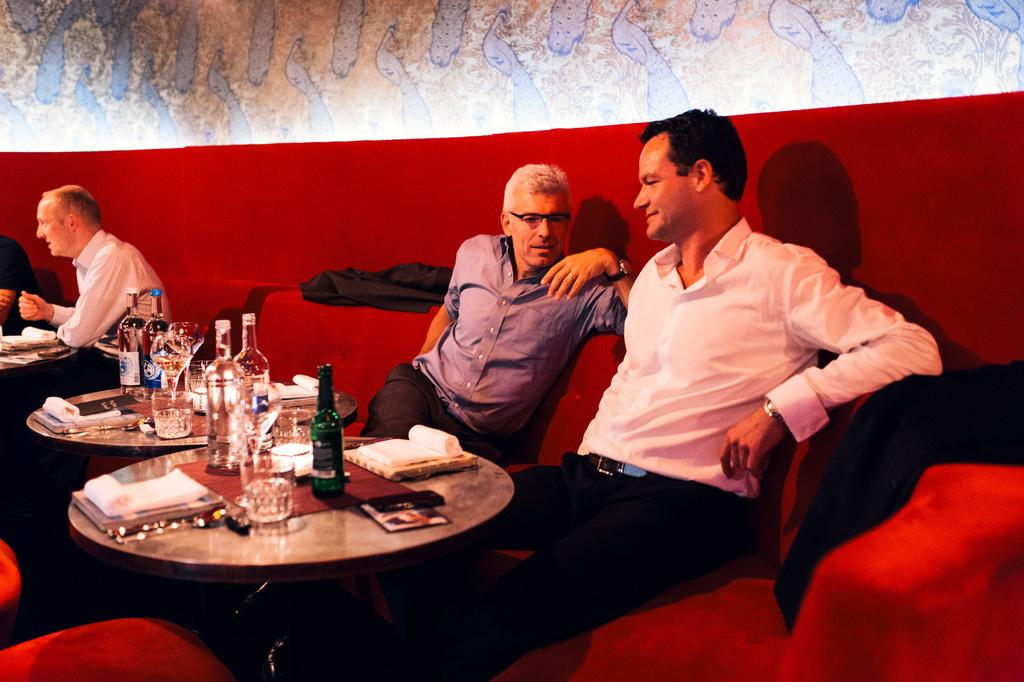What are the people in the image doing? The persons in the image are sitting on a sofa set. What is located in front of the sofa set? There is a table in front of the sofa set. What items can be seen on the table? There is a bottle, books, and a glass containing a drink on the table. What type of cart is being used to transport the books in the image? There is no cart present in the image; the books are on the table. 